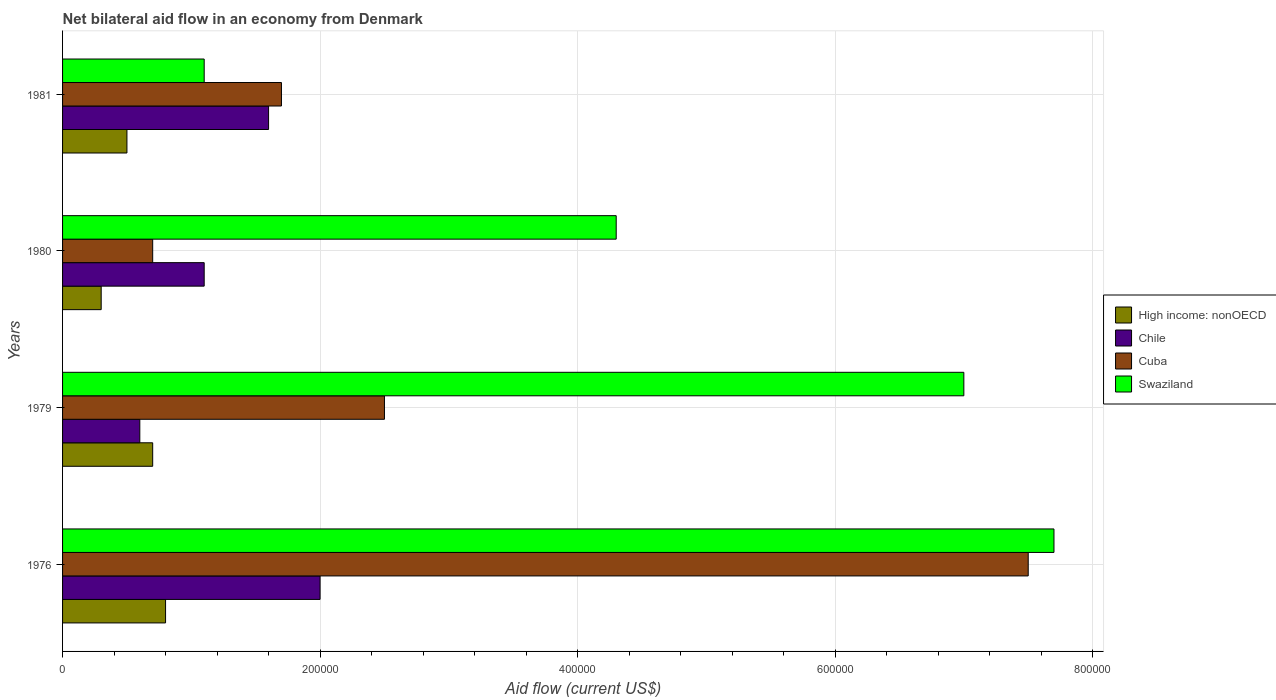How many different coloured bars are there?
Offer a terse response. 4. Are the number of bars per tick equal to the number of legend labels?
Provide a short and direct response. Yes. What is the label of the 3rd group of bars from the top?
Offer a very short reply. 1979. What is the net bilateral aid flow in High income: nonOECD in 1980?
Your response must be concise. 3.00e+04. Across all years, what is the maximum net bilateral aid flow in Chile?
Your answer should be compact. 2.00e+05. Across all years, what is the minimum net bilateral aid flow in Cuba?
Your answer should be compact. 7.00e+04. In which year was the net bilateral aid flow in High income: nonOECD maximum?
Give a very brief answer. 1976. What is the difference between the net bilateral aid flow in Chile in 1979 and that in 1980?
Offer a very short reply. -5.00e+04. What is the average net bilateral aid flow in High income: nonOECD per year?
Make the answer very short. 5.75e+04. In how many years, is the net bilateral aid flow in Cuba greater than 80000 US$?
Give a very brief answer. 3. What is the ratio of the net bilateral aid flow in Swaziland in 1976 to that in 1980?
Offer a terse response. 1.79. Is the net bilateral aid flow in Cuba in 1976 less than that in 1981?
Keep it short and to the point. No. Is the difference between the net bilateral aid flow in Cuba in 1976 and 1980 greater than the difference between the net bilateral aid flow in Swaziland in 1976 and 1980?
Make the answer very short. Yes. What is the difference between the highest and the second highest net bilateral aid flow in Cuba?
Make the answer very short. 5.00e+05. What is the difference between the highest and the lowest net bilateral aid flow in Swaziland?
Your answer should be very brief. 6.60e+05. Is the sum of the net bilateral aid flow in High income: nonOECD in 1979 and 1981 greater than the maximum net bilateral aid flow in Cuba across all years?
Provide a short and direct response. No. Is it the case that in every year, the sum of the net bilateral aid flow in High income: nonOECD and net bilateral aid flow in Cuba is greater than the net bilateral aid flow in Chile?
Provide a succinct answer. No. Are all the bars in the graph horizontal?
Ensure brevity in your answer.  Yes. What is the difference between two consecutive major ticks on the X-axis?
Offer a very short reply. 2.00e+05. Are the values on the major ticks of X-axis written in scientific E-notation?
Ensure brevity in your answer.  No. Does the graph contain grids?
Make the answer very short. Yes. Where does the legend appear in the graph?
Provide a succinct answer. Center right. How many legend labels are there?
Your response must be concise. 4. How are the legend labels stacked?
Make the answer very short. Vertical. What is the title of the graph?
Provide a short and direct response. Net bilateral aid flow in an economy from Denmark. What is the label or title of the Y-axis?
Offer a terse response. Years. What is the Aid flow (current US$) in High income: nonOECD in 1976?
Your answer should be compact. 8.00e+04. What is the Aid flow (current US$) in Cuba in 1976?
Offer a very short reply. 7.50e+05. What is the Aid flow (current US$) in Swaziland in 1976?
Ensure brevity in your answer.  7.70e+05. What is the Aid flow (current US$) in High income: nonOECD in 1979?
Provide a short and direct response. 7.00e+04. What is the Aid flow (current US$) in Cuba in 1979?
Keep it short and to the point. 2.50e+05. What is the Aid flow (current US$) of Swaziland in 1979?
Keep it short and to the point. 7.00e+05. What is the Aid flow (current US$) in High income: nonOECD in 1980?
Make the answer very short. 3.00e+04. What is the Aid flow (current US$) in Cuba in 1980?
Keep it short and to the point. 7.00e+04. What is the Aid flow (current US$) of High income: nonOECD in 1981?
Give a very brief answer. 5.00e+04. What is the Aid flow (current US$) of Chile in 1981?
Your answer should be compact. 1.60e+05. What is the Aid flow (current US$) in Cuba in 1981?
Offer a very short reply. 1.70e+05. Across all years, what is the maximum Aid flow (current US$) in High income: nonOECD?
Give a very brief answer. 8.00e+04. Across all years, what is the maximum Aid flow (current US$) of Chile?
Ensure brevity in your answer.  2.00e+05. Across all years, what is the maximum Aid flow (current US$) of Cuba?
Provide a succinct answer. 7.50e+05. Across all years, what is the maximum Aid flow (current US$) of Swaziland?
Offer a very short reply. 7.70e+05. Across all years, what is the minimum Aid flow (current US$) in High income: nonOECD?
Keep it short and to the point. 3.00e+04. Across all years, what is the minimum Aid flow (current US$) in Cuba?
Give a very brief answer. 7.00e+04. Across all years, what is the minimum Aid flow (current US$) in Swaziland?
Your answer should be very brief. 1.10e+05. What is the total Aid flow (current US$) in High income: nonOECD in the graph?
Your response must be concise. 2.30e+05. What is the total Aid flow (current US$) in Chile in the graph?
Provide a succinct answer. 5.30e+05. What is the total Aid flow (current US$) in Cuba in the graph?
Ensure brevity in your answer.  1.24e+06. What is the total Aid flow (current US$) of Swaziland in the graph?
Ensure brevity in your answer.  2.01e+06. What is the difference between the Aid flow (current US$) of Swaziland in 1976 and that in 1979?
Offer a terse response. 7.00e+04. What is the difference between the Aid flow (current US$) in High income: nonOECD in 1976 and that in 1980?
Your answer should be compact. 5.00e+04. What is the difference between the Aid flow (current US$) in Cuba in 1976 and that in 1980?
Provide a short and direct response. 6.80e+05. What is the difference between the Aid flow (current US$) in Cuba in 1976 and that in 1981?
Offer a terse response. 5.80e+05. What is the difference between the Aid flow (current US$) in Swaziland in 1976 and that in 1981?
Your response must be concise. 6.60e+05. What is the difference between the Aid flow (current US$) in Chile in 1979 and that in 1980?
Your response must be concise. -5.00e+04. What is the difference between the Aid flow (current US$) of Cuba in 1979 and that in 1980?
Your answer should be compact. 1.80e+05. What is the difference between the Aid flow (current US$) in Swaziland in 1979 and that in 1981?
Offer a very short reply. 5.90e+05. What is the difference between the Aid flow (current US$) of Cuba in 1980 and that in 1981?
Offer a terse response. -1.00e+05. What is the difference between the Aid flow (current US$) of High income: nonOECD in 1976 and the Aid flow (current US$) of Chile in 1979?
Your response must be concise. 2.00e+04. What is the difference between the Aid flow (current US$) of High income: nonOECD in 1976 and the Aid flow (current US$) of Swaziland in 1979?
Your answer should be very brief. -6.20e+05. What is the difference between the Aid flow (current US$) of Chile in 1976 and the Aid flow (current US$) of Swaziland in 1979?
Your response must be concise. -5.00e+05. What is the difference between the Aid flow (current US$) of Cuba in 1976 and the Aid flow (current US$) of Swaziland in 1979?
Your answer should be very brief. 5.00e+04. What is the difference between the Aid flow (current US$) in High income: nonOECD in 1976 and the Aid flow (current US$) in Chile in 1980?
Your answer should be very brief. -3.00e+04. What is the difference between the Aid flow (current US$) in High income: nonOECD in 1976 and the Aid flow (current US$) in Swaziland in 1980?
Your answer should be very brief. -3.50e+05. What is the difference between the Aid flow (current US$) of Chile in 1976 and the Aid flow (current US$) of Cuba in 1980?
Keep it short and to the point. 1.30e+05. What is the difference between the Aid flow (current US$) of High income: nonOECD in 1976 and the Aid flow (current US$) of Cuba in 1981?
Make the answer very short. -9.00e+04. What is the difference between the Aid flow (current US$) in Chile in 1976 and the Aid flow (current US$) in Cuba in 1981?
Provide a succinct answer. 3.00e+04. What is the difference between the Aid flow (current US$) of Cuba in 1976 and the Aid flow (current US$) of Swaziland in 1981?
Your answer should be very brief. 6.40e+05. What is the difference between the Aid flow (current US$) of High income: nonOECD in 1979 and the Aid flow (current US$) of Cuba in 1980?
Provide a short and direct response. 0. What is the difference between the Aid flow (current US$) of High income: nonOECD in 1979 and the Aid flow (current US$) of Swaziland in 1980?
Give a very brief answer. -3.60e+05. What is the difference between the Aid flow (current US$) of Chile in 1979 and the Aid flow (current US$) of Cuba in 1980?
Offer a very short reply. -10000. What is the difference between the Aid flow (current US$) of Chile in 1979 and the Aid flow (current US$) of Swaziland in 1980?
Keep it short and to the point. -3.70e+05. What is the difference between the Aid flow (current US$) of Cuba in 1979 and the Aid flow (current US$) of Swaziland in 1980?
Make the answer very short. -1.80e+05. What is the difference between the Aid flow (current US$) in High income: nonOECD in 1979 and the Aid flow (current US$) in Swaziland in 1981?
Your answer should be very brief. -4.00e+04. What is the difference between the Aid flow (current US$) of Cuba in 1979 and the Aid flow (current US$) of Swaziland in 1981?
Your answer should be compact. 1.40e+05. What is the difference between the Aid flow (current US$) in High income: nonOECD in 1980 and the Aid flow (current US$) in Cuba in 1981?
Provide a short and direct response. -1.40e+05. What is the difference between the Aid flow (current US$) of High income: nonOECD in 1980 and the Aid flow (current US$) of Swaziland in 1981?
Provide a succinct answer. -8.00e+04. What is the difference between the Aid flow (current US$) in Chile in 1980 and the Aid flow (current US$) in Cuba in 1981?
Your response must be concise. -6.00e+04. What is the difference between the Aid flow (current US$) of Chile in 1980 and the Aid flow (current US$) of Swaziland in 1981?
Offer a terse response. 0. What is the average Aid flow (current US$) in High income: nonOECD per year?
Offer a terse response. 5.75e+04. What is the average Aid flow (current US$) of Chile per year?
Ensure brevity in your answer.  1.32e+05. What is the average Aid flow (current US$) of Cuba per year?
Offer a very short reply. 3.10e+05. What is the average Aid flow (current US$) of Swaziland per year?
Make the answer very short. 5.02e+05. In the year 1976, what is the difference between the Aid flow (current US$) in High income: nonOECD and Aid flow (current US$) in Chile?
Offer a terse response. -1.20e+05. In the year 1976, what is the difference between the Aid flow (current US$) in High income: nonOECD and Aid flow (current US$) in Cuba?
Ensure brevity in your answer.  -6.70e+05. In the year 1976, what is the difference between the Aid flow (current US$) in High income: nonOECD and Aid flow (current US$) in Swaziland?
Offer a terse response. -6.90e+05. In the year 1976, what is the difference between the Aid flow (current US$) in Chile and Aid flow (current US$) in Cuba?
Your answer should be very brief. -5.50e+05. In the year 1976, what is the difference between the Aid flow (current US$) in Chile and Aid flow (current US$) in Swaziland?
Offer a terse response. -5.70e+05. In the year 1976, what is the difference between the Aid flow (current US$) in Cuba and Aid flow (current US$) in Swaziland?
Provide a succinct answer. -2.00e+04. In the year 1979, what is the difference between the Aid flow (current US$) of High income: nonOECD and Aid flow (current US$) of Chile?
Give a very brief answer. 10000. In the year 1979, what is the difference between the Aid flow (current US$) of High income: nonOECD and Aid flow (current US$) of Swaziland?
Provide a short and direct response. -6.30e+05. In the year 1979, what is the difference between the Aid flow (current US$) of Chile and Aid flow (current US$) of Swaziland?
Make the answer very short. -6.40e+05. In the year 1979, what is the difference between the Aid flow (current US$) in Cuba and Aid flow (current US$) in Swaziland?
Give a very brief answer. -4.50e+05. In the year 1980, what is the difference between the Aid flow (current US$) in High income: nonOECD and Aid flow (current US$) in Chile?
Your answer should be very brief. -8.00e+04. In the year 1980, what is the difference between the Aid flow (current US$) in High income: nonOECD and Aid flow (current US$) in Swaziland?
Provide a succinct answer. -4.00e+05. In the year 1980, what is the difference between the Aid flow (current US$) in Chile and Aid flow (current US$) in Cuba?
Offer a terse response. 4.00e+04. In the year 1980, what is the difference between the Aid flow (current US$) in Chile and Aid flow (current US$) in Swaziland?
Provide a succinct answer. -3.20e+05. In the year 1980, what is the difference between the Aid flow (current US$) in Cuba and Aid flow (current US$) in Swaziland?
Your response must be concise. -3.60e+05. In the year 1981, what is the difference between the Aid flow (current US$) in High income: nonOECD and Aid flow (current US$) in Swaziland?
Provide a succinct answer. -6.00e+04. In the year 1981, what is the difference between the Aid flow (current US$) in Cuba and Aid flow (current US$) in Swaziland?
Offer a terse response. 6.00e+04. What is the ratio of the Aid flow (current US$) of High income: nonOECD in 1976 to that in 1979?
Keep it short and to the point. 1.14. What is the ratio of the Aid flow (current US$) of Cuba in 1976 to that in 1979?
Offer a terse response. 3. What is the ratio of the Aid flow (current US$) in High income: nonOECD in 1976 to that in 1980?
Your answer should be compact. 2.67. What is the ratio of the Aid flow (current US$) of Chile in 1976 to that in 1980?
Offer a very short reply. 1.82. What is the ratio of the Aid flow (current US$) in Cuba in 1976 to that in 1980?
Offer a very short reply. 10.71. What is the ratio of the Aid flow (current US$) in Swaziland in 1976 to that in 1980?
Your response must be concise. 1.79. What is the ratio of the Aid flow (current US$) in High income: nonOECD in 1976 to that in 1981?
Keep it short and to the point. 1.6. What is the ratio of the Aid flow (current US$) in Chile in 1976 to that in 1981?
Give a very brief answer. 1.25. What is the ratio of the Aid flow (current US$) in Cuba in 1976 to that in 1981?
Your answer should be compact. 4.41. What is the ratio of the Aid flow (current US$) of Swaziland in 1976 to that in 1981?
Your answer should be very brief. 7. What is the ratio of the Aid flow (current US$) of High income: nonOECD in 1979 to that in 1980?
Provide a short and direct response. 2.33. What is the ratio of the Aid flow (current US$) of Chile in 1979 to that in 1980?
Provide a short and direct response. 0.55. What is the ratio of the Aid flow (current US$) in Cuba in 1979 to that in 1980?
Provide a short and direct response. 3.57. What is the ratio of the Aid flow (current US$) in Swaziland in 1979 to that in 1980?
Offer a terse response. 1.63. What is the ratio of the Aid flow (current US$) in High income: nonOECD in 1979 to that in 1981?
Make the answer very short. 1.4. What is the ratio of the Aid flow (current US$) in Cuba in 1979 to that in 1981?
Make the answer very short. 1.47. What is the ratio of the Aid flow (current US$) in Swaziland in 1979 to that in 1981?
Ensure brevity in your answer.  6.36. What is the ratio of the Aid flow (current US$) in Chile in 1980 to that in 1981?
Make the answer very short. 0.69. What is the ratio of the Aid flow (current US$) in Cuba in 1980 to that in 1981?
Give a very brief answer. 0.41. What is the ratio of the Aid flow (current US$) in Swaziland in 1980 to that in 1981?
Your answer should be compact. 3.91. What is the difference between the highest and the second highest Aid flow (current US$) in High income: nonOECD?
Provide a succinct answer. 10000. What is the difference between the highest and the second highest Aid flow (current US$) of Chile?
Give a very brief answer. 4.00e+04. What is the difference between the highest and the second highest Aid flow (current US$) in Cuba?
Provide a succinct answer. 5.00e+05. What is the difference between the highest and the lowest Aid flow (current US$) in High income: nonOECD?
Provide a short and direct response. 5.00e+04. What is the difference between the highest and the lowest Aid flow (current US$) of Chile?
Offer a terse response. 1.40e+05. What is the difference between the highest and the lowest Aid flow (current US$) of Cuba?
Your response must be concise. 6.80e+05. 